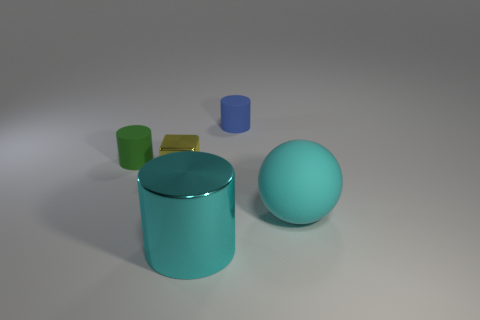The thing that is the same color as the large ball is what size?
Your answer should be very brief. Large. How many objects are either cyan cubes or large cyan metallic things?
Offer a very short reply. 1. What is the shape of the rubber object that is both in front of the blue thing and to the right of the shiny cylinder?
Provide a short and direct response. Sphere. There is a large cyan rubber object; is it the same shape as the large thing left of the small blue rubber cylinder?
Offer a terse response. No. There is a large metallic cylinder; are there any tiny objects on the right side of it?
Offer a terse response. Yes. What is the material of the thing that is the same color as the matte sphere?
Ensure brevity in your answer.  Metal. What number of spheres are either large brown things or cyan rubber things?
Your answer should be very brief. 1. Is the shape of the blue matte object the same as the yellow metallic thing?
Your answer should be very brief. No. There is a shiny object behind the big shiny object; how big is it?
Ensure brevity in your answer.  Small. Is there a large sphere that has the same color as the small metallic object?
Ensure brevity in your answer.  No. 